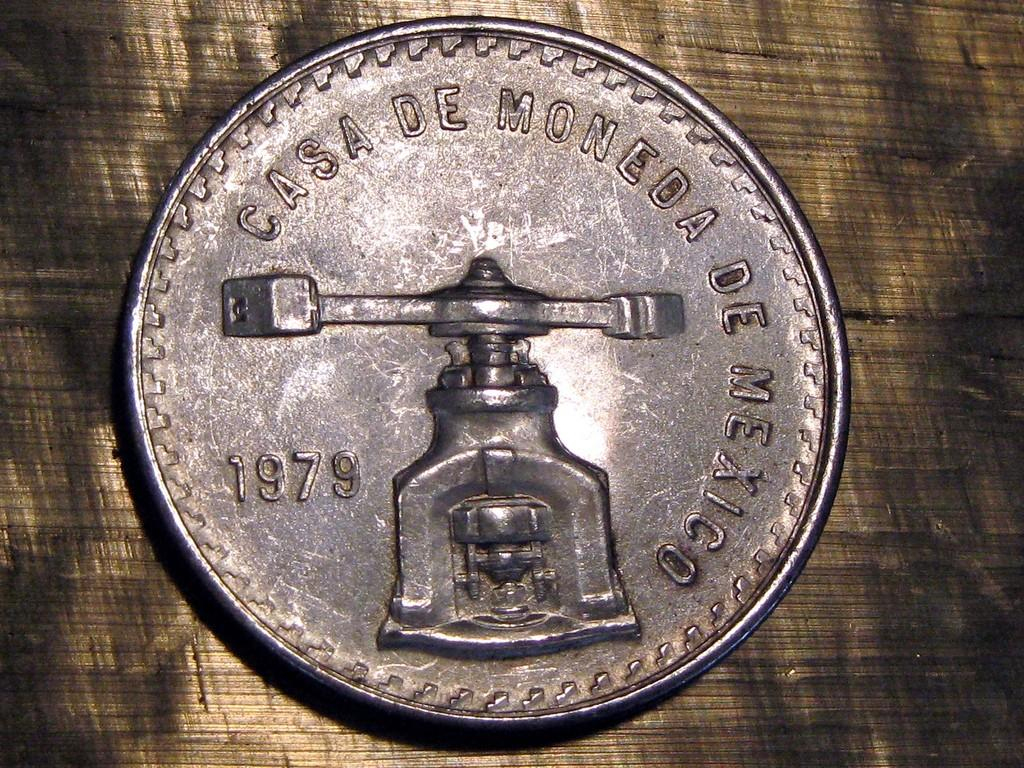<image>
Give a short and clear explanation of the subsequent image. A vintage coin from 1979 is engraved with Casa De Moneda De Mexico. 